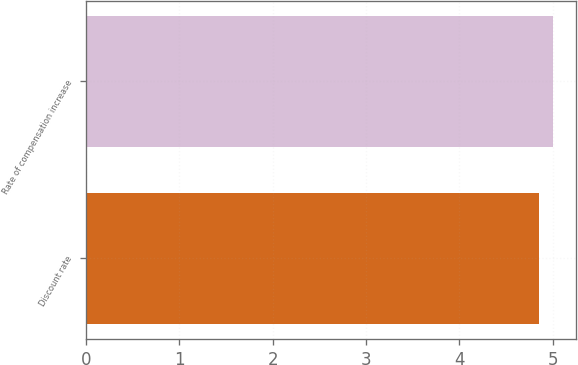<chart> <loc_0><loc_0><loc_500><loc_500><bar_chart><fcel>Discount rate<fcel>Rate of compensation increase<nl><fcel>4.85<fcel>5<nl></chart> 